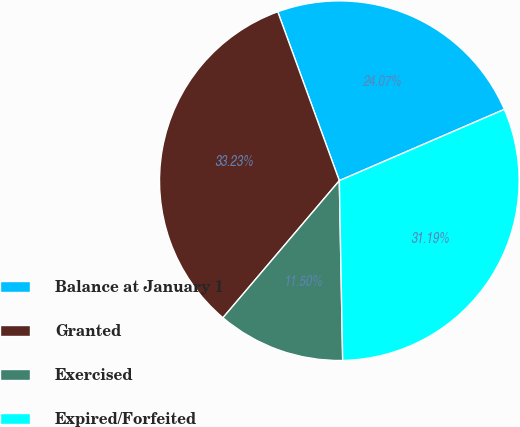Convert chart to OTSL. <chart><loc_0><loc_0><loc_500><loc_500><pie_chart><fcel>Balance at January 1<fcel>Granted<fcel>Exercised<fcel>Expired/Forfeited<nl><fcel>24.07%<fcel>33.23%<fcel>11.5%<fcel>31.19%<nl></chart> 